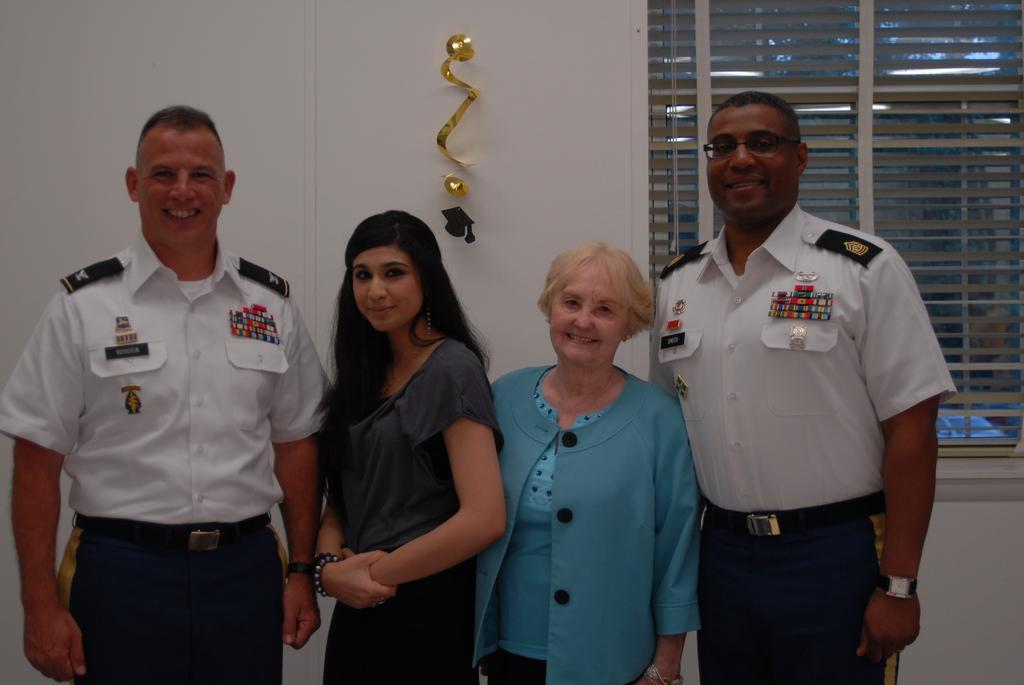In one or two sentences, can you explain what this image depicts? In this image we can see people standing on the floor. In the background there are hooks and blinds. 